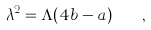<formula> <loc_0><loc_0><loc_500><loc_500>\lambda ^ { 2 } = \Lambda ( 4 b - a ) \quad ,</formula> 